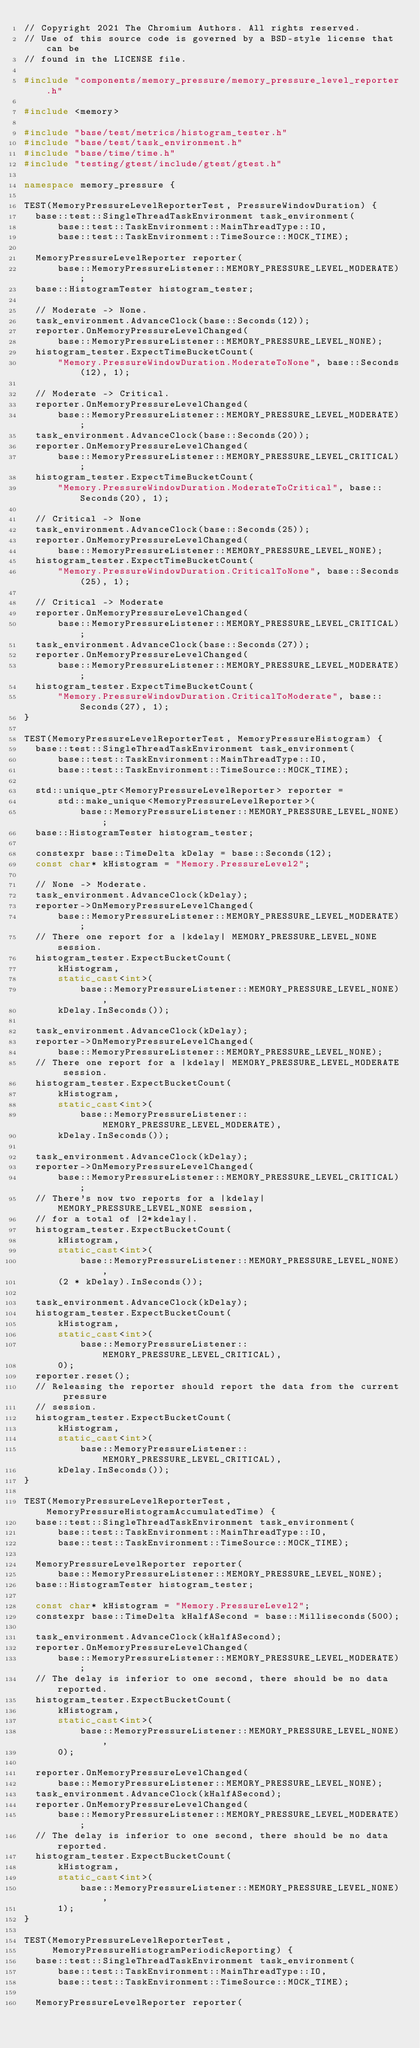<code> <loc_0><loc_0><loc_500><loc_500><_C++_>// Copyright 2021 The Chromium Authors. All rights reserved.
// Use of this source code is governed by a BSD-style license that can be
// found in the LICENSE file.

#include "components/memory_pressure/memory_pressure_level_reporter.h"

#include <memory>

#include "base/test/metrics/histogram_tester.h"
#include "base/test/task_environment.h"
#include "base/time/time.h"
#include "testing/gtest/include/gtest/gtest.h"

namespace memory_pressure {

TEST(MemoryPressureLevelReporterTest, PressureWindowDuration) {
  base::test::SingleThreadTaskEnvironment task_environment(
      base::test::TaskEnvironment::MainThreadType::IO,
      base::test::TaskEnvironment::TimeSource::MOCK_TIME);

  MemoryPressureLevelReporter reporter(
      base::MemoryPressureListener::MEMORY_PRESSURE_LEVEL_MODERATE);
  base::HistogramTester histogram_tester;

  // Moderate -> None.
  task_environment.AdvanceClock(base::Seconds(12));
  reporter.OnMemoryPressureLevelChanged(
      base::MemoryPressureListener::MEMORY_PRESSURE_LEVEL_NONE);
  histogram_tester.ExpectTimeBucketCount(
      "Memory.PressureWindowDuration.ModerateToNone", base::Seconds(12), 1);

  // Moderate -> Critical.
  reporter.OnMemoryPressureLevelChanged(
      base::MemoryPressureListener::MEMORY_PRESSURE_LEVEL_MODERATE);
  task_environment.AdvanceClock(base::Seconds(20));
  reporter.OnMemoryPressureLevelChanged(
      base::MemoryPressureListener::MEMORY_PRESSURE_LEVEL_CRITICAL);
  histogram_tester.ExpectTimeBucketCount(
      "Memory.PressureWindowDuration.ModerateToCritical", base::Seconds(20), 1);

  // Critical -> None
  task_environment.AdvanceClock(base::Seconds(25));
  reporter.OnMemoryPressureLevelChanged(
      base::MemoryPressureListener::MEMORY_PRESSURE_LEVEL_NONE);
  histogram_tester.ExpectTimeBucketCount(
      "Memory.PressureWindowDuration.CriticalToNone", base::Seconds(25), 1);

  // Critical -> Moderate
  reporter.OnMemoryPressureLevelChanged(
      base::MemoryPressureListener::MEMORY_PRESSURE_LEVEL_CRITICAL);
  task_environment.AdvanceClock(base::Seconds(27));
  reporter.OnMemoryPressureLevelChanged(
      base::MemoryPressureListener::MEMORY_PRESSURE_LEVEL_MODERATE);
  histogram_tester.ExpectTimeBucketCount(
      "Memory.PressureWindowDuration.CriticalToModerate", base::Seconds(27), 1);
}

TEST(MemoryPressureLevelReporterTest, MemoryPressureHistogram) {
  base::test::SingleThreadTaskEnvironment task_environment(
      base::test::TaskEnvironment::MainThreadType::IO,
      base::test::TaskEnvironment::TimeSource::MOCK_TIME);

  std::unique_ptr<MemoryPressureLevelReporter> reporter =
      std::make_unique<MemoryPressureLevelReporter>(
          base::MemoryPressureListener::MEMORY_PRESSURE_LEVEL_NONE);
  base::HistogramTester histogram_tester;

  constexpr base::TimeDelta kDelay = base::Seconds(12);
  const char* kHistogram = "Memory.PressureLevel2";

  // None -> Moderate.
  task_environment.AdvanceClock(kDelay);
  reporter->OnMemoryPressureLevelChanged(
      base::MemoryPressureListener::MEMORY_PRESSURE_LEVEL_MODERATE);
  // There one report for a |kdelay| MEMORY_PRESSURE_LEVEL_NONE session.
  histogram_tester.ExpectBucketCount(
      kHistogram,
      static_cast<int>(
          base::MemoryPressureListener::MEMORY_PRESSURE_LEVEL_NONE),
      kDelay.InSeconds());

  task_environment.AdvanceClock(kDelay);
  reporter->OnMemoryPressureLevelChanged(
      base::MemoryPressureListener::MEMORY_PRESSURE_LEVEL_NONE);
  // There one report for a |kdelay| MEMORY_PRESSURE_LEVEL_MODERATE session.
  histogram_tester.ExpectBucketCount(
      kHistogram,
      static_cast<int>(
          base::MemoryPressureListener::MEMORY_PRESSURE_LEVEL_MODERATE),
      kDelay.InSeconds());

  task_environment.AdvanceClock(kDelay);
  reporter->OnMemoryPressureLevelChanged(
      base::MemoryPressureListener::MEMORY_PRESSURE_LEVEL_CRITICAL);
  // There's now two reports for a |kdelay| MEMORY_PRESSURE_LEVEL_NONE session,
  // for a total of |2*kdelay|.
  histogram_tester.ExpectBucketCount(
      kHistogram,
      static_cast<int>(
          base::MemoryPressureListener::MEMORY_PRESSURE_LEVEL_NONE),
      (2 * kDelay).InSeconds());

  task_environment.AdvanceClock(kDelay);
  histogram_tester.ExpectBucketCount(
      kHistogram,
      static_cast<int>(
          base::MemoryPressureListener::MEMORY_PRESSURE_LEVEL_CRITICAL),
      0);
  reporter.reset();
  // Releasing the reporter should report the data from the current pressure
  // session.
  histogram_tester.ExpectBucketCount(
      kHistogram,
      static_cast<int>(
          base::MemoryPressureListener::MEMORY_PRESSURE_LEVEL_CRITICAL),
      kDelay.InSeconds());
}

TEST(MemoryPressureLevelReporterTest, MemoryPressureHistogramAccumulatedTime) {
  base::test::SingleThreadTaskEnvironment task_environment(
      base::test::TaskEnvironment::MainThreadType::IO,
      base::test::TaskEnvironment::TimeSource::MOCK_TIME);

  MemoryPressureLevelReporter reporter(
      base::MemoryPressureListener::MEMORY_PRESSURE_LEVEL_NONE);
  base::HistogramTester histogram_tester;

  const char* kHistogram = "Memory.PressureLevel2";
  constexpr base::TimeDelta kHalfASecond = base::Milliseconds(500);

  task_environment.AdvanceClock(kHalfASecond);
  reporter.OnMemoryPressureLevelChanged(
      base::MemoryPressureListener::MEMORY_PRESSURE_LEVEL_MODERATE);
  // The delay is inferior to one second, there should be no data reported.
  histogram_tester.ExpectBucketCount(
      kHistogram,
      static_cast<int>(
          base::MemoryPressureListener::MEMORY_PRESSURE_LEVEL_NONE),
      0);

  reporter.OnMemoryPressureLevelChanged(
      base::MemoryPressureListener::MEMORY_PRESSURE_LEVEL_NONE);
  task_environment.AdvanceClock(kHalfASecond);
  reporter.OnMemoryPressureLevelChanged(
      base::MemoryPressureListener::MEMORY_PRESSURE_LEVEL_MODERATE);
  // The delay is inferior to one second, there should be no data reported.
  histogram_tester.ExpectBucketCount(
      kHistogram,
      static_cast<int>(
          base::MemoryPressureListener::MEMORY_PRESSURE_LEVEL_NONE),
      1);
}

TEST(MemoryPressureLevelReporterTest,
     MemoryPressureHistogramPeriodicReporting) {
  base::test::SingleThreadTaskEnvironment task_environment(
      base::test::TaskEnvironment::MainThreadType::IO,
      base::test::TaskEnvironment::TimeSource::MOCK_TIME);

  MemoryPressureLevelReporter reporter(</code> 